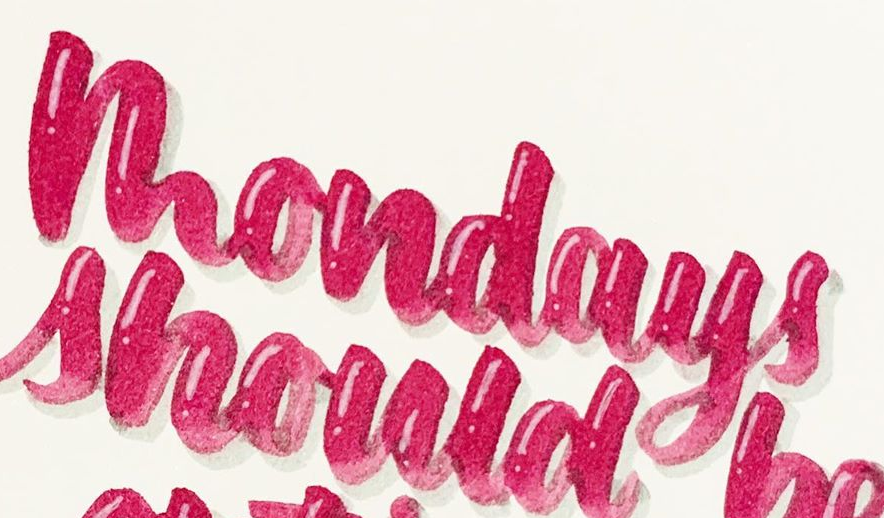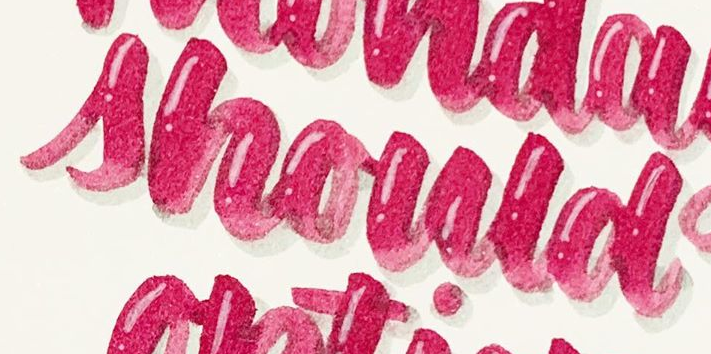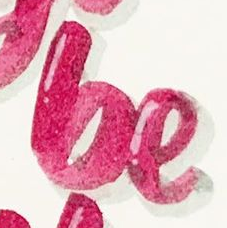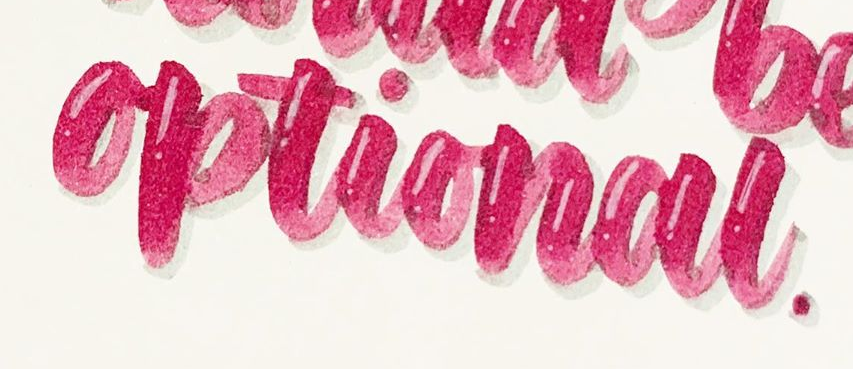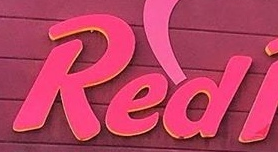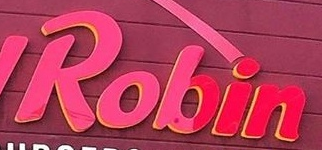Read the text content from these images in order, separated by a semicolon. mondays; should; be; optional; Red; Robin 